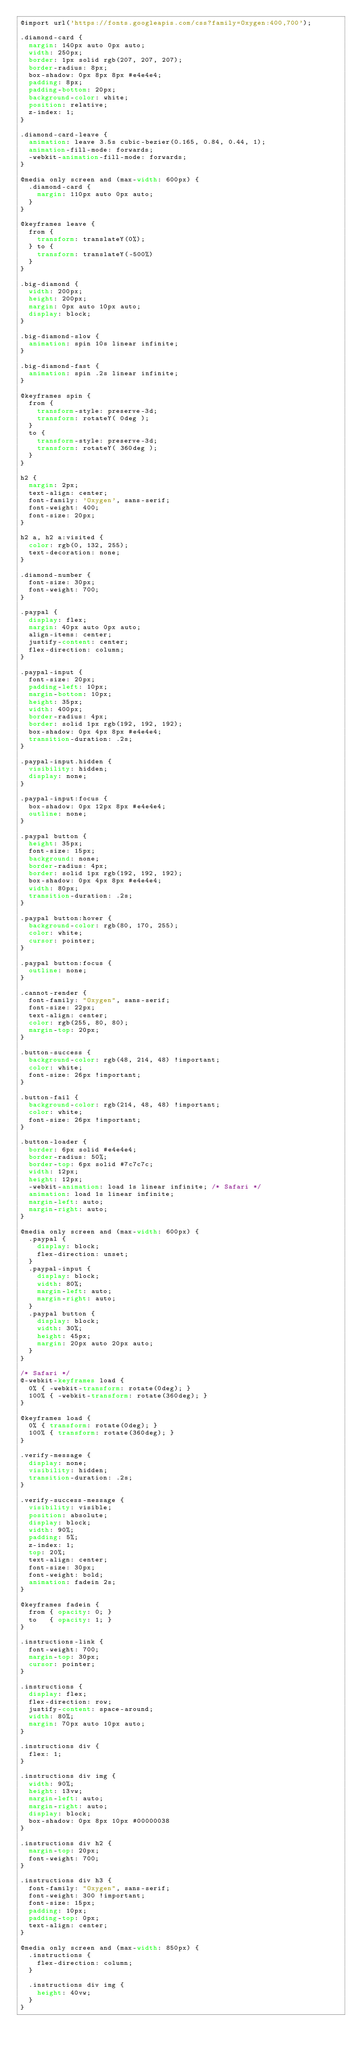<code> <loc_0><loc_0><loc_500><loc_500><_CSS_>@import url('https://fonts.googleapis.com/css?family=Oxygen:400,700');

.diamond-card {
  margin: 140px auto 0px auto;
  width: 250px;
  border: 1px solid rgb(207, 207, 207);
  border-radius: 8px;
  box-shadow: 0px 8px 8px #e4e4e4;
  padding: 8px;
  padding-bottom: 20px;
  background-color: white;
  position: relative;
  z-index: 1;
}

.diamond-card-leave {
  animation: leave 3.5s cubic-bezier(0.165, 0.84, 0.44, 1);
  animation-fill-mode: forwards;
  -webkit-animation-fill-mode: forwards;
}

@media only screen and (max-width: 600px) {
  .diamond-card {
    margin: 110px auto 0px auto;
  }
}

@keyframes leave {
  from {
    transform: translateY(0%);
  } to {
    transform: translateY(-500%)
  }
}

.big-diamond {
  width: 200px;
  height: 200px;
  margin: 0px auto 10px auto;
  display: block;
}

.big-diamond-slow {
  animation: spin 10s linear infinite;
}

.big-diamond-fast {
  animation: spin .2s linear infinite;
}

@keyframes spin {
  from {
    transform-style: preserve-3d;
    transform: rotateY( 0deg );
  }
  to {
    transform-style: preserve-3d;
    transform: rotateY( 360deg );
  }
}

h2 {
  margin: 2px;
  text-align: center;
  font-family: 'Oxygen', sans-serif;
  font-weight: 400;
  font-size: 20px;
}

h2 a, h2 a:visited {
  color: rgb(0, 132, 255);
  text-decoration: none;
}

.diamond-number {
  font-size: 30px;
  font-weight: 700;
}

.paypal {
  display: flex;
  margin: 40px auto 0px auto;
  align-items: center;
  justify-content: center;
  flex-direction: column;
}

.paypal-input {
  font-size: 20px;
  padding-left: 10px;
  margin-bottom: 10px;
  height: 35px;
  width: 400px;
  border-radius: 4px;
  border: solid 1px rgb(192, 192, 192);
  box-shadow: 0px 4px 8px #e4e4e4;
  transition-duration: .2s;
}

.paypal-input.hidden {
  visibility: hidden;
  display: none;
}

.paypal-input:focus {
  box-shadow: 0px 12px 8px #e4e4e4;
  outline: none;
}

.paypal button {
  height: 35px;
  font-size: 15px;
  background: none;
  border-radius: 4px;
  border: solid 1px rgb(192, 192, 192);
  box-shadow: 0px 4px 8px #e4e4e4;
  width: 80px;
  transition-duration: .2s;
}

.paypal button:hover {
  background-color: rgb(80, 170, 255);
  color: white;
  cursor: pointer;
}

.paypal button:focus {
  outline: none;
}

.cannot-render {
  font-family: "Oxygen", sans-serif;
  font-size: 22px;
  text-align: center;
  color: rgb(255, 80, 80);
  margin-top: 20px;
}

.button-success {
  background-color: rgb(48, 214, 48) !important;
  color: white;
  font-size: 26px !important;
}

.button-fail {
  background-color: rgb(214, 48, 48) !important;
  color: white;
  font-size: 26px !important;
}

.button-loader {
  border: 6px solid #e4e4e4;
  border-radius: 50%;
  border-top: 6px solid #7c7c7c;
  width: 12px;
  height: 12px;
  -webkit-animation: load 1s linear infinite; /* Safari */
  animation: load 1s linear infinite;
  margin-left: auto;
  margin-right: auto;
}

@media only screen and (max-width: 600px) {
  .paypal {
    display: block;
    flex-direction: unset;
  }
  .paypal-input {
    display: block;
    width: 80%;
    margin-left: auto;
    margin-right: auto;
  }
  .paypal button {
    display: block;
    width: 30%;
    height: 45px;
    margin: 20px auto 20px auto;
  }
}

/* Safari */
@-webkit-keyframes load {
  0% { -webkit-transform: rotate(0deg); }
  100% { -webkit-transform: rotate(360deg); }
}

@keyframes load {
  0% { transform: rotate(0deg); }
  100% { transform: rotate(360deg); }
}

.verify-message {
  display: none;
  visibility: hidden;
  transition-duration: .2s;
}

.verify-success-message {
  visibility: visible;
  position: absolute;
  display: block;
  width: 90%;
  padding: 5%;
  z-index: 1;
  top: 20%;
  text-align: center;
  font-size: 30px;
  font-weight: bold;
  animation: fadein 2s;
}

@keyframes fadein {
  from { opacity: 0; }
  to   { opacity: 1; }
}

.instructions-link {
  font-weight: 700;
  margin-top: 30px;
  cursor: pointer;
}

.instructions {
  display: flex;
  flex-direction: row;
  justify-content: space-around;
  width: 80%;
  margin: 70px auto 10px auto;
}

.instructions div {
  flex: 1;
}

.instructions div img {
  width: 90%;
  height: 13vw;
  margin-left: auto;
  margin-right: auto;
  display: block;
  box-shadow: 0px 8px 10px #00000038
}

.instructions div h2 {
  margin-top: 20px;
  font-weight: 700;
}

.instructions div h3 {
  font-family: "Oxygen", sans-serif;
  font-weight: 300 !important;
  font-size: 15px;
  padding: 10px;
  padding-top: 0px;
  text-align: center;
}

@media only screen and (max-width: 850px) {
  .instructions {
    flex-direction: column;
  }

  .instructions div img {
    height: 40vw;
  }
}</code> 